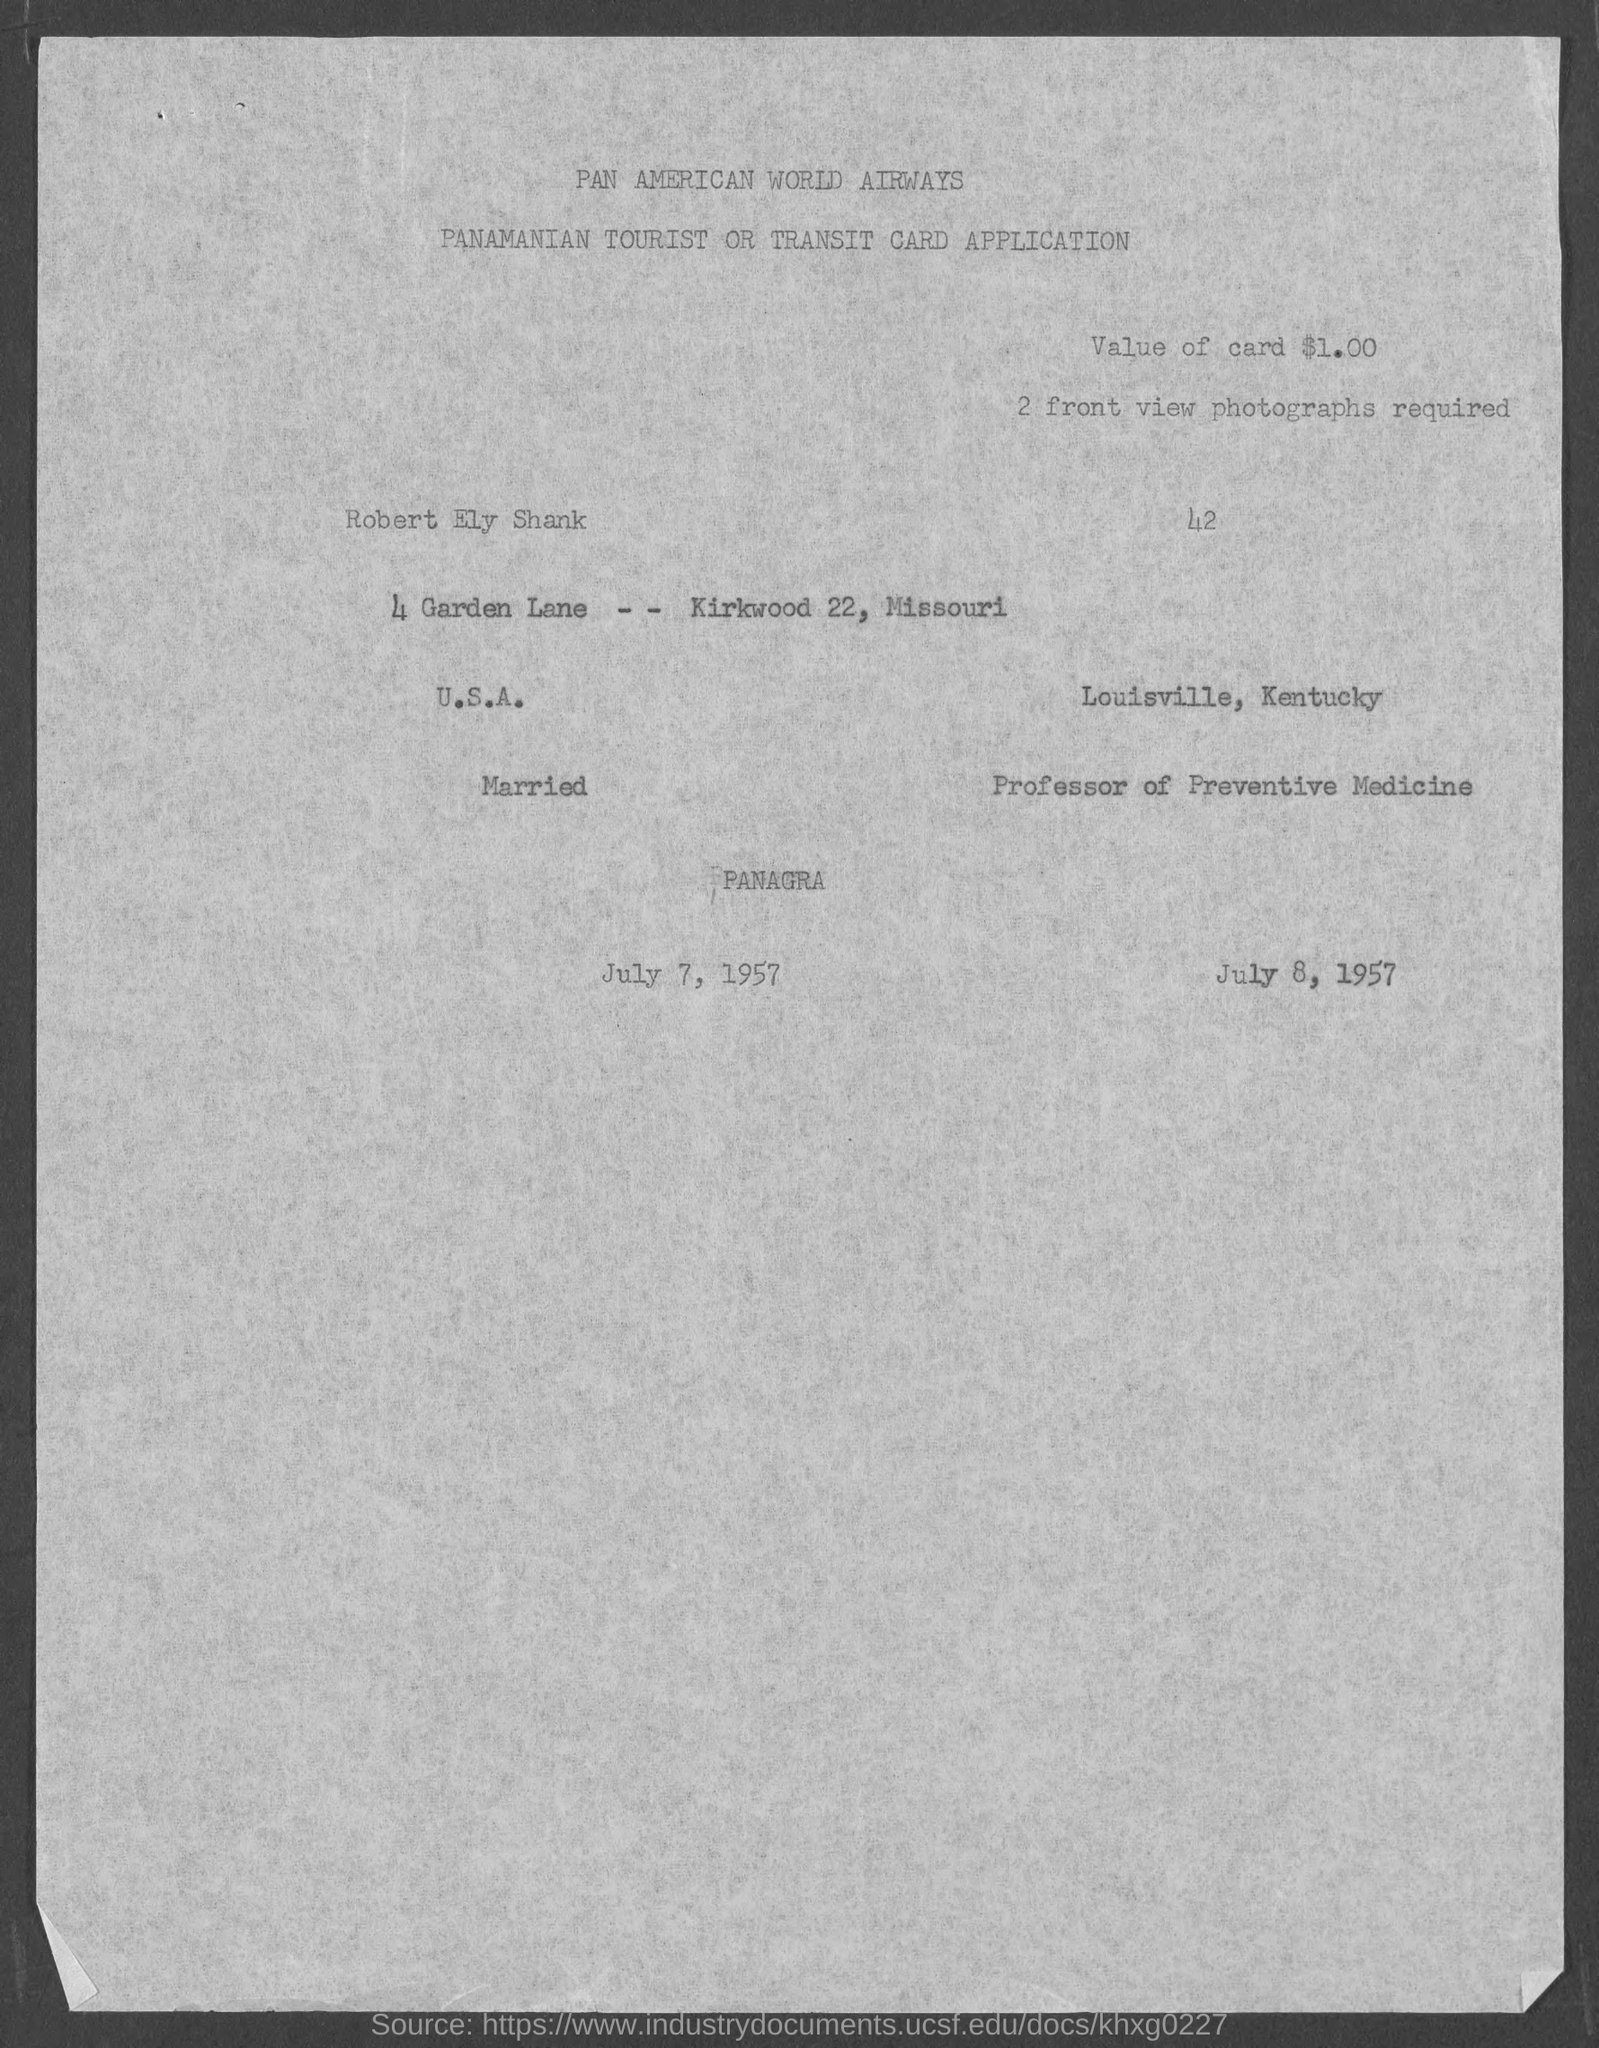Draw attention to some important aspects in this diagram. The value of the card is one dollar. 